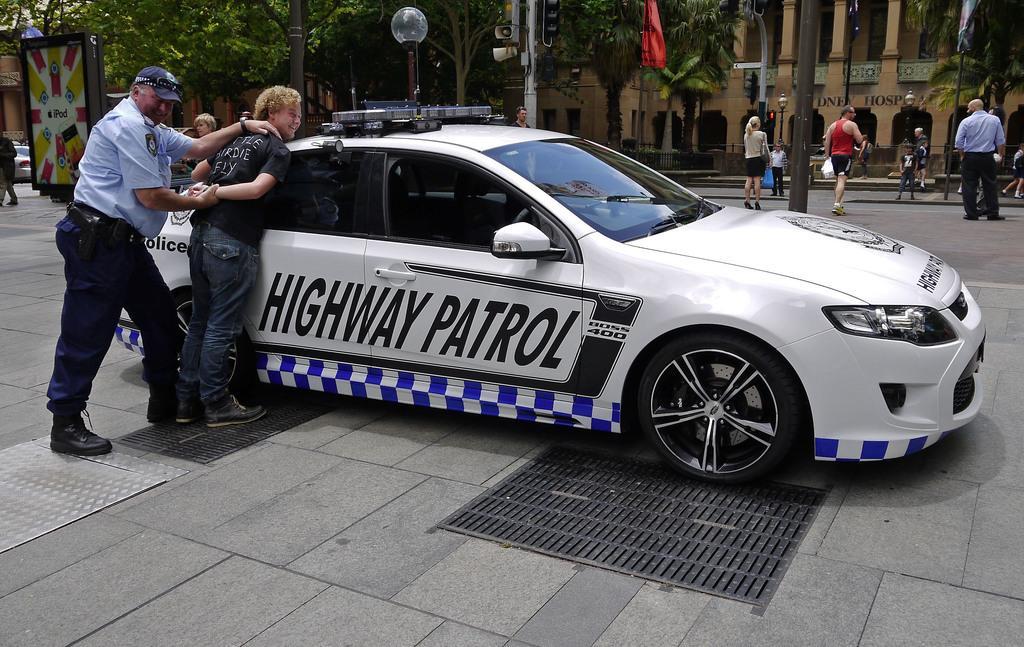In one or two sentences, can you explain what this image depicts? On the left side, there is a in a uniform, holding a hand of a person who is in black color T-shirt and leaning on a white color car which is on the road, on which there are three manholes. In the background, there are persons, poles, a hoarding, a light attached to a pole, speakers and buildings. 